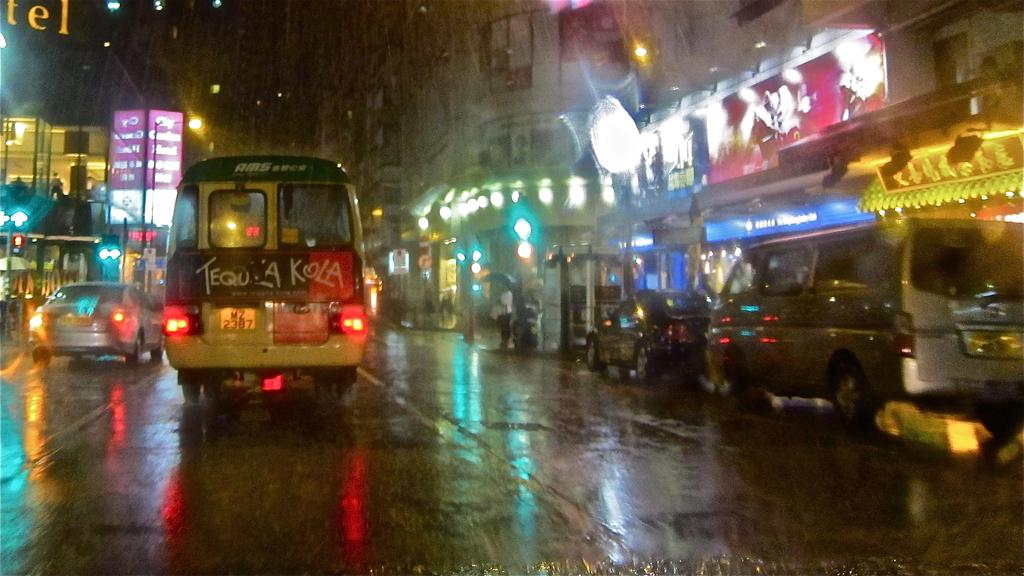<image>
Give a short and clear explanation of the subsequent image. a street with many places around and a van that says Kola 